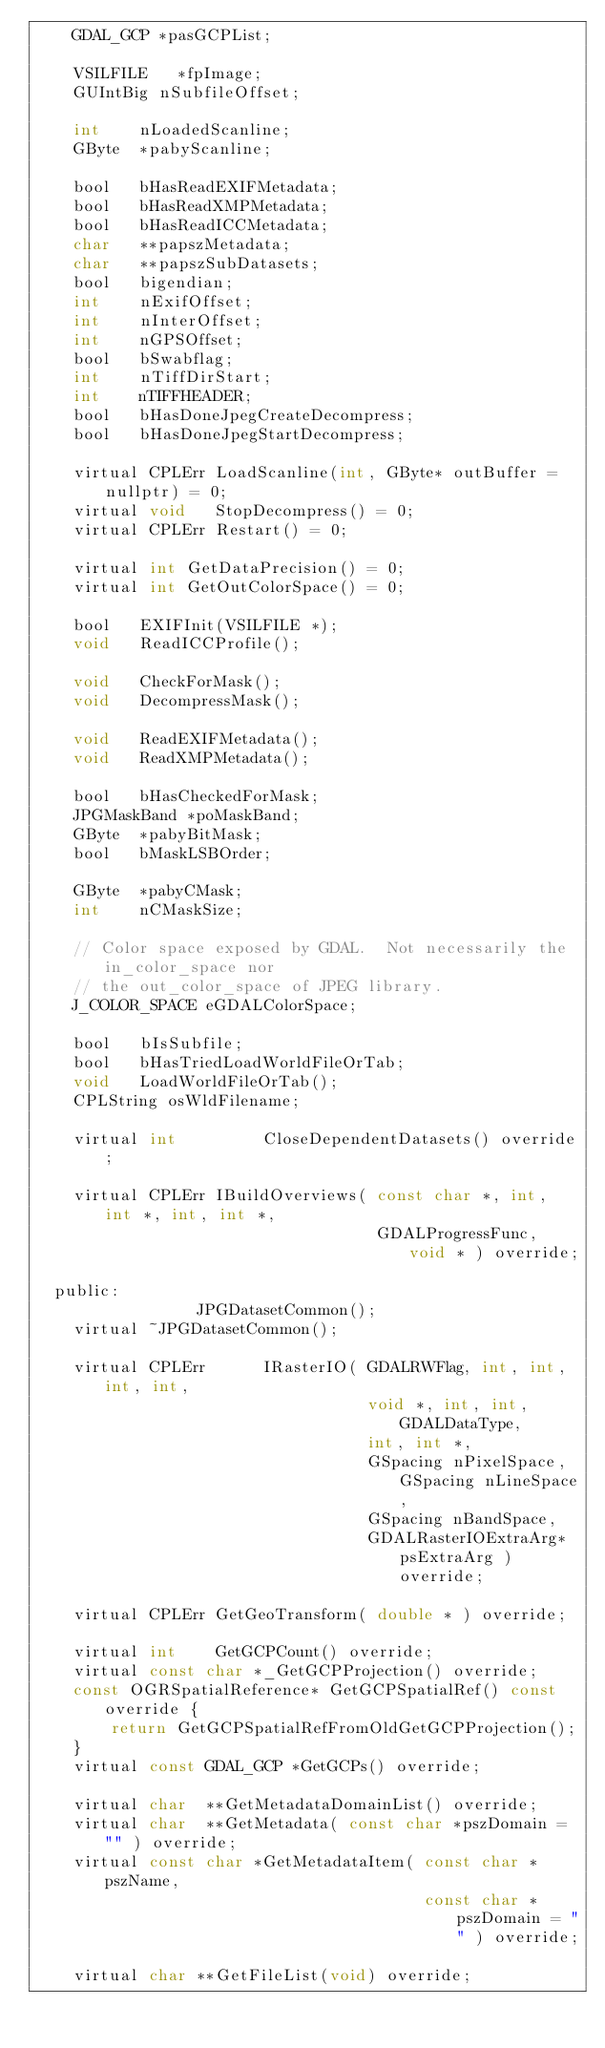Convert code to text. <code><loc_0><loc_0><loc_500><loc_500><_C_>    GDAL_GCP *pasGCPList;

    VSILFILE   *fpImage;
    GUIntBig nSubfileOffset;

    int    nLoadedScanline;
    GByte  *pabyScanline;

    bool   bHasReadEXIFMetadata;
    bool   bHasReadXMPMetadata;
    bool   bHasReadICCMetadata;
    char   **papszMetadata;
    char   **papszSubDatasets;
    bool   bigendian;
    int    nExifOffset;
    int    nInterOffset;
    int    nGPSOffset;
    bool   bSwabflag;
    int    nTiffDirStart;
    int    nTIFFHEADER;
    bool   bHasDoneJpegCreateDecompress;
    bool   bHasDoneJpegStartDecompress;

    virtual CPLErr LoadScanline(int, GByte* outBuffer = nullptr) = 0;
    virtual void   StopDecompress() = 0;
    virtual CPLErr Restart() = 0;

    virtual int GetDataPrecision() = 0;
    virtual int GetOutColorSpace() = 0;

    bool   EXIFInit(VSILFILE *);
    void   ReadICCProfile();

    void   CheckForMask();
    void   DecompressMask();

    void   ReadEXIFMetadata();
    void   ReadXMPMetadata();

    bool   bHasCheckedForMask;
    JPGMaskBand *poMaskBand;
    GByte  *pabyBitMask;
    bool   bMaskLSBOrder;

    GByte  *pabyCMask;
    int    nCMaskSize;

    // Color space exposed by GDAL.  Not necessarily the in_color_space nor
    // the out_color_space of JPEG library.
    J_COLOR_SPACE eGDALColorSpace;

    bool   bIsSubfile;
    bool   bHasTriedLoadWorldFileOrTab;
    void   LoadWorldFileOrTab();
    CPLString osWldFilename;

    virtual int         CloseDependentDatasets() override;

    virtual CPLErr IBuildOverviews( const char *, int, int *, int, int *,
                                    GDALProgressFunc, void * ) override;

  public:
                 JPGDatasetCommon();
    virtual ~JPGDatasetCommon();

    virtual CPLErr      IRasterIO( GDALRWFlag, int, int, int, int,
                                   void *, int, int, GDALDataType,
                                   int, int *,
                                   GSpacing nPixelSpace, GSpacing nLineSpace,
                                   GSpacing nBandSpace,
                                   GDALRasterIOExtraArg* psExtraArg ) override;

    virtual CPLErr GetGeoTransform( double * ) override;

    virtual int    GetGCPCount() override;
    virtual const char *_GetGCPProjection() override;
    const OGRSpatialReference* GetGCPSpatialRef() const override {
        return GetGCPSpatialRefFromOldGetGCPProjection();
    }
    virtual const GDAL_GCP *GetGCPs() override;

    virtual char  **GetMetadataDomainList() override;
    virtual char  **GetMetadata( const char *pszDomain = "" ) override;
    virtual const char *GetMetadataItem( const char *pszName,
                                         const char *pszDomain = "" ) override;

    virtual char **GetFileList(void) override;
</code> 